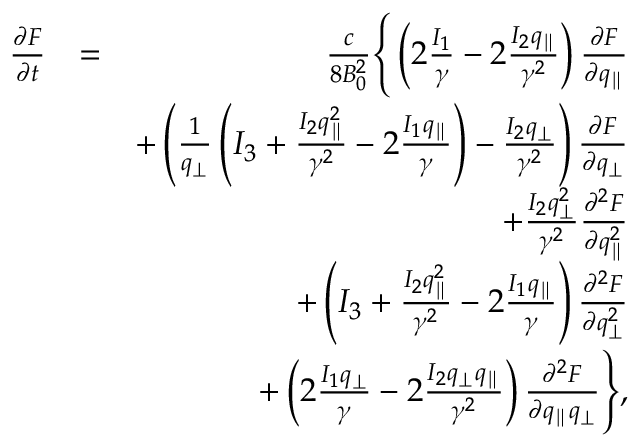Convert formula to latex. <formula><loc_0><loc_0><loc_500><loc_500>\begin{array} { r l r } { \frac { \partial F } { \partial t } } & { = } & { \frac { c } { 8 B _ { 0 } ^ { 2 } } \left \{ \left ( 2 \frac { I _ { 1 } } { \gamma } - 2 \frac { I _ { 2 } q _ { \| } } { \gamma ^ { 2 } } \right ) \frac { \partial F } { \partial q _ { \| } } } \\ & { + \left ( \frac { 1 } { q _ { \perp } } \left ( I _ { 3 } + \frac { I _ { 2 } q _ { \| } ^ { 2 } } { \gamma ^ { 2 } } - 2 \frac { I _ { 1 } q _ { \| } } { \gamma } \right ) - \frac { I _ { 2 } q _ { \perp } } { \gamma ^ { 2 } } \right ) \frac { \partial F } { \partial q _ { \perp } } } \\ & { + \frac { I _ { 2 } q _ { \perp } ^ { 2 } } { \gamma ^ { 2 } } \frac { \partial ^ { 2 } F } { \partial q _ { \| } ^ { 2 } } } \\ & { + \left ( I _ { 3 } + \frac { I _ { 2 } q _ { \| } ^ { 2 } } { \gamma ^ { 2 } } - 2 \frac { I _ { 1 } q _ { \| } } { \gamma } \right ) \frac { \partial ^ { 2 } F } { \partial q _ { \perp } ^ { 2 } } } \\ & { + \left ( 2 \frac { I _ { 1 } q _ { \perp } } { \gamma } - 2 \frac { I _ { 2 } q _ { \perp } q _ { \| } } { \gamma ^ { 2 } } \right ) \frac { \partial ^ { 2 } F } { \partial q _ { \| } q _ { \perp } } \right \} , } \end{array}</formula> 